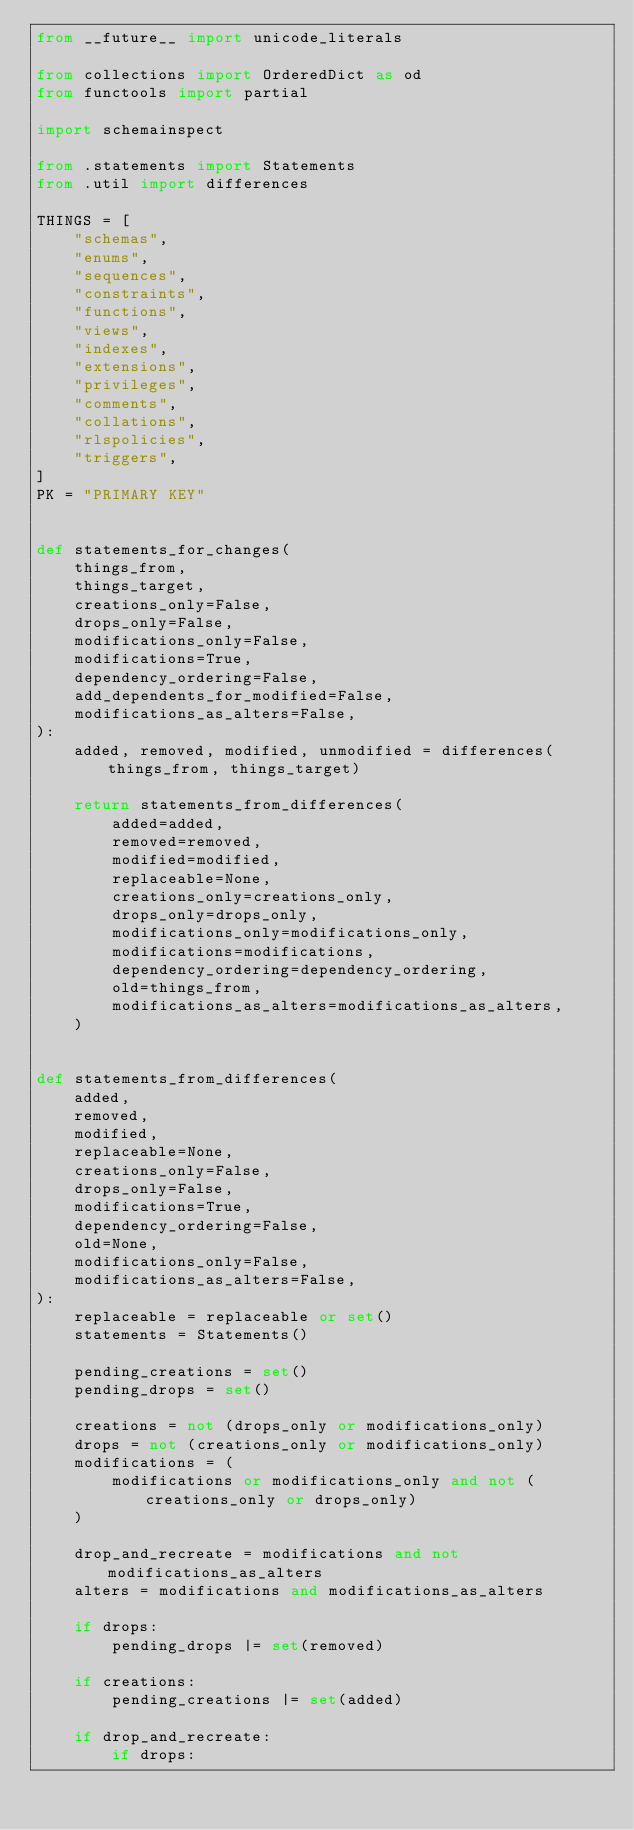<code> <loc_0><loc_0><loc_500><loc_500><_Python_>from __future__ import unicode_literals

from collections import OrderedDict as od
from functools import partial

import schemainspect

from .statements import Statements
from .util import differences

THINGS = [
    "schemas",
    "enums",
    "sequences",
    "constraints",
    "functions",
    "views",
    "indexes",
    "extensions",
    "privileges",
    "comments",
    "collations",
    "rlspolicies",
    "triggers",
]
PK = "PRIMARY KEY"


def statements_for_changes(
    things_from,
    things_target,
    creations_only=False,
    drops_only=False,
    modifications_only=False,
    modifications=True,
    dependency_ordering=False,
    add_dependents_for_modified=False,
    modifications_as_alters=False,
):
    added, removed, modified, unmodified = differences(things_from, things_target)

    return statements_from_differences(
        added=added,
        removed=removed,
        modified=modified,
        replaceable=None,
        creations_only=creations_only,
        drops_only=drops_only,
        modifications_only=modifications_only,
        modifications=modifications,
        dependency_ordering=dependency_ordering,
        old=things_from,
        modifications_as_alters=modifications_as_alters,
    )


def statements_from_differences(
    added,
    removed,
    modified,
    replaceable=None,
    creations_only=False,
    drops_only=False,
    modifications=True,
    dependency_ordering=False,
    old=None,
    modifications_only=False,
    modifications_as_alters=False,
):
    replaceable = replaceable or set()
    statements = Statements()

    pending_creations = set()
    pending_drops = set()

    creations = not (drops_only or modifications_only)
    drops = not (creations_only or modifications_only)
    modifications = (
        modifications or modifications_only and not (creations_only or drops_only)
    )

    drop_and_recreate = modifications and not modifications_as_alters
    alters = modifications and modifications_as_alters

    if drops:
        pending_drops |= set(removed)

    if creations:
        pending_creations |= set(added)

    if drop_and_recreate:
        if drops:</code> 